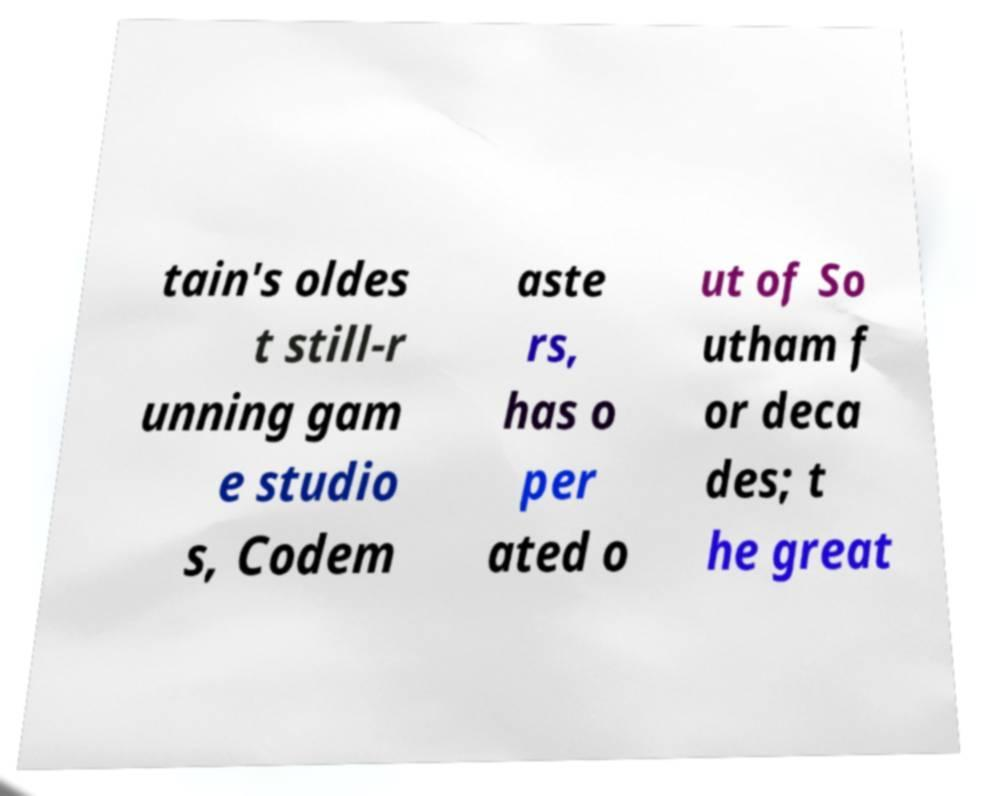I need the written content from this picture converted into text. Can you do that? tain's oldes t still-r unning gam e studio s, Codem aste rs, has o per ated o ut of So utham f or deca des; t he great 